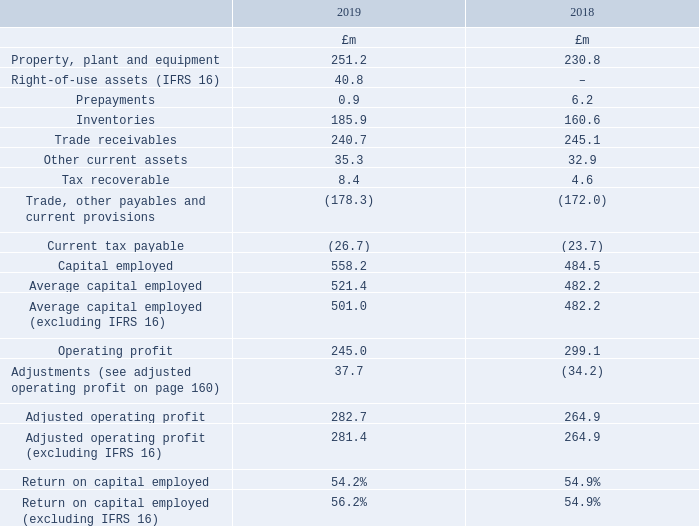2 Alternative performance measures continued
Return on capital employed (ROCE)
ROCE measures effective management of fixed assets and working capital relative to the profitability of the business. It is calculated as adjusted operating profit divided by average capital employed. More information on ROCE can be found in the Capital Employed and ROCE sections of the Financial Review on page 57.
An analysis of the components is as follows:
What does ROCE measure? Effective management of fixed assets and working capital relative to the profitability of the business. How is ROCE calculated? Adjusted operating profit divided by average capital employed. What are the components factored in when calculating the adjusted operating profit? Operating profit, adjustments. In which year was the amount of other current assets larger? 35.3>32.9
Answer: 2019. What was the change in the adjusted operating profit in 2019 from 2018?
Answer scale should be: million. 282.7-264.9
Answer: 17.8. What was the percentage change in the adjusted operating profit in 2019 from 2018?
Answer scale should be: percent. (282.7-264.9)/264.9
Answer: 6.72. 